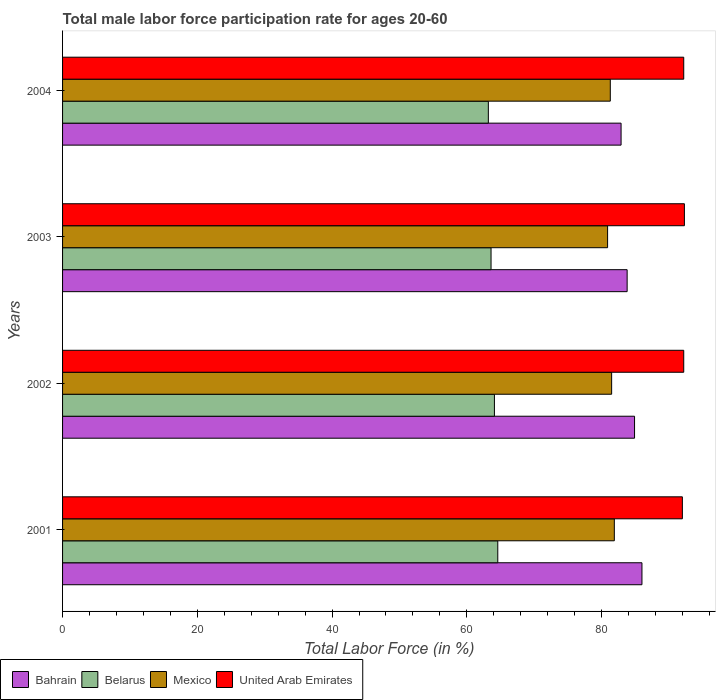How many groups of bars are there?
Offer a terse response. 4. Are the number of bars on each tick of the Y-axis equal?
Your response must be concise. Yes. How many bars are there on the 4th tick from the bottom?
Your answer should be very brief. 4. What is the label of the 3rd group of bars from the top?
Provide a succinct answer. 2002. What is the male labor force participation rate in Belarus in 2004?
Keep it short and to the point. 63.2. Across all years, what is the minimum male labor force participation rate in Belarus?
Make the answer very short. 63.2. What is the total male labor force participation rate in Bahrain in the graph?
Give a very brief answer. 337.6. What is the difference between the male labor force participation rate in Belarus in 2003 and that in 2004?
Keep it short and to the point. 0.4. What is the difference between the male labor force participation rate in Mexico in 2004 and the male labor force participation rate in Bahrain in 2003?
Ensure brevity in your answer.  -2.5. What is the average male labor force participation rate in United Arab Emirates per year?
Offer a terse response. 92.17. In the year 2003, what is the difference between the male labor force participation rate in Bahrain and male labor force participation rate in Belarus?
Provide a short and direct response. 20.2. In how many years, is the male labor force participation rate in United Arab Emirates greater than 68 %?
Your response must be concise. 4. What is the ratio of the male labor force participation rate in Mexico in 2002 to that in 2003?
Give a very brief answer. 1.01. Is the male labor force participation rate in Belarus in 2003 less than that in 2004?
Provide a succinct answer. No. What is the difference between the highest and the second highest male labor force participation rate in Bahrain?
Your answer should be compact. 1.1. What is the difference between the highest and the lowest male labor force participation rate in United Arab Emirates?
Provide a short and direct response. 0.3. Is the sum of the male labor force participation rate in Belarus in 2003 and 2004 greater than the maximum male labor force participation rate in Bahrain across all years?
Provide a short and direct response. Yes. What does the 1st bar from the top in 2001 represents?
Give a very brief answer. United Arab Emirates. What does the 3rd bar from the bottom in 2003 represents?
Your answer should be very brief. Mexico. How many bars are there?
Give a very brief answer. 16. Are all the bars in the graph horizontal?
Offer a terse response. Yes. How many years are there in the graph?
Provide a short and direct response. 4. What is the difference between two consecutive major ticks on the X-axis?
Provide a short and direct response. 20. Does the graph contain any zero values?
Ensure brevity in your answer.  No. Does the graph contain grids?
Your answer should be compact. No. How are the legend labels stacked?
Keep it short and to the point. Horizontal. What is the title of the graph?
Your response must be concise. Total male labor force participation rate for ages 20-60. What is the label or title of the X-axis?
Provide a succinct answer. Total Labor Force (in %). What is the label or title of the Y-axis?
Offer a terse response. Years. What is the Total Labor Force (in %) of Bahrain in 2001?
Your answer should be compact. 86. What is the Total Labor Force (in %) in Belarus in 2001?
Your response must be concise. 64.6. What is the Total Labor Force (in %) of Mexico in 2001?
Ensure brevity in your answer.  81.9. What is the Total Labor Force (in %) of United Arab Emirates in 2001?
Keep it short and to the point. 92. What is the Total Labor Force (in %) in Bahrain in 2002?
Provide a short and direct response. 84.9. What is the Total Labor Force (in %) of Belarus in 2002?
Ensure brevity in your answer.  64.1. What is the Total Labor Force (in %) of Mexico in 2002?
Your answer should be very brief. 81.5. What is the Total Labor Force (in %) of United Arab Emirates in 2002?
Your answer should be very brief. 92.2. What is the Total Labor Force (in %) in Bahrain in 2003?
Your answer should be compact. 83.8. What is the Total Labor Force (in %) of Belarus in 2003?
Your response must be concise. 63.6. What is the Total Labor Force (in %) in Mexico in 2003?
Offer a very short reply. 80.9. What is the Total Labor Force (in %) in United Arab Emirates in 2003?
Ensure brevity in your answer.  92.3. What is the Total Labor Force (in %) of Bahrain in 2004?
Your answer should be very brief. 82.9. What is the Total Labor Force (in %) of Belarus in 2004?
Give a very brief answer. 63.2. What is the Total Labor Force (in %) in Mexico in 2004?
Provide a succinct answer. 81.3. What is the Total Labor Force (in %) of United Arab Emirates in 2004?
Provide a succinct answer. 92.2. Across all years, what is the maximum Total Labor Force (in %) in Bahrain?
Make the answer very short. 86. Across all years, what is the maximum Total Labor Force (in %) in Belarus?
Provide a short and direct response. 64.6. Across all years, what is the maximum Total Labor Force (in %) in Mexico?
Give a very brief answer. 81.9. Across all years, what is the maximum Total Labor Force (in %) in United Arab Emirates?
Give a very brief answer. 92.3. Across all years, what is the minimum Total Labor Force (in %) in Bahrain?
Your response must be concise. 82.9. Across all years, what is the minimum Total Labor Force (in %) of Belarus?
Provide a succinct answer. 63.2. Across all years, what is the minimum Total Labor Force (in %) of Mexico?
Give a very brief answer. 80.9. Across all years, what is the minimum Total Labor Force (in %) of United Arab Emirates?
Provide a succinct answer. 92. What is the total Total Labor Force (in %) of Bahrain in the graph?
Your answer should be compact. 337.6. What is the total Total Labor Force (in %) of Belarus in the graph?
Your response must be concise. 255.5. What is the total Total Labor Force (in %) in Mexico in the graph?
Ensure brevity in your answer.  325.6. What is the total Total Labor Force (in %) in United Arab Emirates in the graph?
Your answer should be compact. 368.7. What is the difference between the Total Labor Force (in %) in Bahrain in 2001 and that in 2002?
Your response must be concise. 1.1. What is the difference between the Total Labor Force (in %) in Belarus in 2001 and that in 2002?
Provide a short and direct response. 0.5. What is the difference between the Total Labor Force (in %) of Mexico in 2001 and that in 2002?
Your answer should be very brief. 0.4. What is the difference between the Total Labor Force (in %) of United Arab Emirates in 2001 and that in 2002?
Offer a very short reply. -0.2. What is the difference between the Total Labor Force (in %) in Belarus in 2001 and that in 2003?
Give a very brief answer. 1. What is the difference between the Total Labor Force (in %) of Mexico in 2001 and that in 2003?
Make the answer very short. 1. What is the difference between the Total Labor Force (in %) in Belarus in 2001 and that in 2004?
Provide a short and direct response. 1.4. What is the difference between the Total Labor Force (in %) of Mexico in 2001 and that in 2004?
Your response must be concise. 0.6. What is the difference between the Total Labor Force (in %) in United Arab Emirates in 2001 and that in 2004?
Ensure brevity in your answer.  -0.2. What is the difference between the Total Labor Force (in %) in Bahrain in 2002 and that in 2003?
Provide a short and direct response. 1.1. What is the difference between the Total Labor Force (in %) in Belarus in 2002 and that in 2003?
Your response must be concise. 0.5. What is the difference between the Total Labor Force (in %) in Belarus in 2002 and that in 2004?
Your answer should be very brief. 0.9. What is the difference between the Total Labor Force (in %) of United Arab Emirates in 2002 and that in 2004?
Your answer should be very brief. 0. What is the difference between the Total Labor Force (in %) of Belarus in 2003 and that in 2004?
Provide a succinct answer. 0.4. What is the difference between the Total Labor Force (in %) of Mexico in 2003 and that in 2004?
Offer a terse response. -0.4. What is the difference between the Total Labor Force (in %) of Bahrain in 2001 and the Total Labor Force (in %) of Belarus in 2002?
Give a very brief answer. 21.9. What is the difference between the Total Labor Force (in %) of Belarus in 2001 and the Total Labor Force (in %) of Mexico in 2002?
Ensure brevity in your answer.  -16.9. What is the difference between the Total Labor Force (in %) in Belarus in 2001 and the Total Labor Force (in %) in United Arab Emirates in 2002?
Provide a short and direct response. -27.6. What is the difference between the Total Labor Force (in %) of Bahrain in 2001 and the Total Labor Force (in %) of Belarus in 2003?
Offer a very short reply. 22.4. What is the difference between the Total Labor Force (in %) in Bahrain in 2001 and the Total Labor Force (in %) in Mexico in 2003?
Your answer should be very brief. 5.1. What is the difference between the Total Labor Force (in %) in Belarus in 2001 and the Total Labor Force (in %) in Mexico in 2003?
Offer a very short reply. -16.3. What is the difference between the Total Labor Force (in %) in Belarus in 2001 and the Total Labor Force (in %) in United Arab Emirates in 2003?
Provide a short and direct response. -27.7. What is the difference between the Total Labor Force (in %) in Mexico in 2001 and the Total Labor Force (in %) in United Arab Emirates in 2003?
Offer a terse response. -10.4. What is the difference between the Total Labor Force (in %) in Bahrain in 2001 and the Total Labor Force (in %) in Belarus in 2004?
Keep it short and to the point. 22.8. What is the difference between the Total Labor Force (in %) of Bahrain in 2001 and the Total Labor Force (in %) of Mexico in 2004?
Offer a very short reply. 4.7. What is the difference between the Total Labor Force (in %) in Bahrain in 2001 and the Total Labor Force (in %) in United Arab Emirates in 2004?
Offer a very short reply. -6.2. What is the difference between the Total Labor Force (in %) in Belarus in 2001 and the Total Labor Force (in %) in Mexico in 2004?
Provide a short and direct response. -16.7. What is the difference between the Total Labor Force (in %) of Belarus in 2001 and the Total Labor Force (in %) of United Arab Emirates in 2004?
Your response must be concise. -27.6. What is the difference between the Total Labor Force (in %) of Mexico in 2001 and the Total Labor Force (in %) of United Arab Emirates in 2004?
Give a very brief answer. -10.3. What is the difference between the Total Labor Force (in %) in Bahrain in 2002 and the Total Labor Force (in %) in Belarus in 2003?
Give a very brief answer. 21.3. What is the difference between the Total Labor Force (in %) in Bahrain in 2002 and the Total Labor Force (in %) in Mexico in 2003?
Make the answer very short. 4. What is the difference between the Total Labor Force (in %) of Bahrain in 2002 and the Total Labor Force (in %) of United Arab Emirates in 2003?
Provide a short and direct response. -7.4. What is the difference between the Total Labor Force (in %) of Belarus in 2002 and the Total Labor Force (in %) of Mexico in 2003?
Keep it short and to the point. -16.8. What is the difference between the Total Labor Force (in %) in Belarus in 2002 and the Total Labor Force (in %) in United Arab Emirates in 2003?
Your answer should be very brief. -28.2. What is the difference between the Total Labor Force (in %) of Mexico in 2002 and the Total Labor Force (in %) of United Arab Emirates in 2003?
Ensure brevity in your answer.  -10.8. What is the difference between the Total Labor Force (in %) of Bahrain in 2002 and the Total Labor Force (in %) of Belarus in 2004?
Ensure brevity in your answer.  21.7. What is the difference between the Total Labor Force (in %) in Bahrain in 2002 and the Total Labor Force (in %) in United Arab Emirates in 2004?
Keep it short and to the point. -7.3. What is the difference between the Total Labor Force (in %) of Belarus in 2002 and the Total Labor Force (in %) of Mexico in 2004?
Give a very brief answer. -17.2. What is the difference between the Total Labor Force (in %) in Belarus in 2002 and the Total Labor Force (in %) in United Arab Emirates in 2004?
Your response must be concise. -28.1. What is the difference between the Total Labor Force (in %) in Bahrain in 2003 and the Total Labor Force (in %) in Belarus in 2004?
Make the answer very short. 20.6. What is the difference between the Total Labor Force (in %) of Bahrain in 2003 and the Total Labor Force (in %) of Mexico in 2004?
Offer a terse response. 2.5. What is the difference between the Total Labor Force (in %) in Bahrain in 2003 and the Total Labor Force (in %) in United Arab Emirates in 2004?
Your response must be concise. -8.4. What is the difference between the Total Labor Force (in %) of Belarus in 2003 and the Total Labor Force (in %) of Mexico in 2004?
Offer a very short reply. -17.7. What is the difference between the Total Labor Force (in %) of Belarus in 2003 and the Total Labor Force (in %) of United Arab Emirates in 2004?
Your response must be concise. -28.6. What is the difference between the Total Labor Force (in %) of Mexico in 2003 and the Total Labor Force (in %) of United Arab Emirates in 2004?
Give a very brief answer. -11.3. What is the average Total Labor Force (in %) of Bahrain per year?
Your response must be concise. 84.4. What is the average Total Labor Force (in %) of Belarus per year?
Provide a succinct answer. 63.88. What is the average Total Labor Force (in %) of Mexico per year?
Provide a short and direct response. 81.4. What is the average Total Labor Force (in %) of United Arab Emirates per year?
Make the answer very short. 92.17. In the year 2001, what is the difference between the Total Labor Force (in %) in Bahrain and Total Labor Force (in %) in Belarus?
Provide a short and direct response. 21.4. In the year 2001, what is the difference between the Total Labor Force (in %) in Bahrain and Total Labor Force (in %) in United Arab Emirates?
Provide a succinct answer. -6. In the year 2001, what is the difference between the Total Labor Force (in %) of Belarus and Total Labor Force (in %) of Mexico?
Keep it short and to the point. -17.3. In the year 2001, what is the difference between the Total Labor Force (in %) in Belarus and Total Labor Force (in %) in United Arab Emirates?
Ensure brevity in your answer.  -27.4. In the year 2002, what is the difference between the Total Labor Force (in %) of Bahrain and Total Labor Force (in %) of Belarus?
Your answer should be compact. 20.8. In the year 2002, what is the difference between the Total Labor Force (in %) of Bahrain and Total Labor Force (in %) of United Arab Emirates?
Offer a terse response. -7.3. In the year 2002, what is the difference between the Total Labor Force (in %) of Belarus and Total Labor Force (in %) of Mexico?
Offer a very short reply. -17.4. In the year 2002, what is the difference between the Total Labor Force (in %) of Belarus and Total Labor Force (in %) of United Arab Emirates?
Give a very brief answer. -28.1. In the year 2003, what is the difference between the Total Labor Force (in %) in Bahrain and Total Labor Force (in %) in Belarus?
Make the answer very short. 20.2. In the year 2003, what is the difference between the Total Labor Force (in %) in Belarus and Total Labor Force (in %) in Mexico?
Provide a short and direct response. -17.3. In the year 2003, what is the difference between the Total Labor Force (in %) of Belarus and Total Labor Force (in %) of United Arab Emirates?
Provide a short and direct response. -28.7. In the year 2003, what is the difference between the Total Labor Force (in %) of Mexico and Total Labor Force (in %) of United Arab Emirates?
Your answer should be compact. -11.4. In the year 2004, what is the difference between the Total Labor Force (in %) in Bahrain and Total Labor Force (in %) in Belarus?
Provide a succinct answer. 19.7. In the year 2004, what is the difference between the Total Labor Force (in %) of Belarus and Total Labor Force (in %) of Mexico?
Offer a terse response. -18.1. In the year 2004, what is the difference between the Total Labor Force (in %) of Belarus and Total Labor Force (in %) of United Arab Emirates?
Your response must be concise. -29. What is the ratio of the Total Labor Force (in %) in Belarus in 2001 to that in 2002?
Your answer should be very brief. 1.01. What is the ratio of the Total Labor Force (in %) of Bahrain in 2001 to that in 2003?
Your response must be concise. 1.03. What is the ratio of the Total Labor Force (in %) in Belarus in 2001 to that in 2003?
Keep it short and to the point. 1.02. What is the ratio of the Total Labor Force (in %) in Mexico in 2001 to that in 2003?
Offer a very short reply. 1.01. What is the ratio of the Total Labor Force (in %) in Bahrain in 2001 to that in 2004?
Make the answer very short. 1.04. What is the ratio of the Total Labor Force (in %) in Belarus in 2001 to that in 2004?
Provide a short and direct response. 1.02. What is the ratio of the Total Labor Force (in %) in Mexico in 2001 to that in 2004?
Provide a succinct answer. 1.01. What is the ratio of the Total Labor Force (in %) of Bahrain in 2002 to that in 2003?
Make the answer very short. 1.01. What is the ratio of the Total Labor Force (in %) in Belarus in 2002 to that in 2003?
Your response must be concise. 1.01. What is the ratio of the Total Labor Force (in %) of Mexico in 2002 to that in 2003?
Make the answer very short. 1.01. What is the ratio of the Total Labor Force (in %) in Bahrain in 2002 to that in 2004?
Give a very brief answer. 1.02. What is the ratio of the Total Labor Force (in %) of Belarus in 2002 to that in 2004?
Give a very brief answer. 1.01. What is the ratio of the Total Labor Force (in %) in United Arab Emirates in 2002 to that in 2004?
Keep it short and to the point. 1. What is the ratio of the Total Labor Force (in %) in Bahrain in 2003 to that in 2004?
Your answer should be very brief. 1.01. What is the ratio of the Total Labor Force (in %) in Mexico in 2003 to that in 2004?
Ensure brevity in your answer.  1. What is the difference between the highest and the second highest Total Labor Force (in %) in Bahrain?
Provide a short and direct response. 1.1. What is the difference between the highest and the second highest Total Labor Force (in %) of Belarus?
Make the answer very short. 0.5. What is the difference between the highest and the second highest Total Labor Force (in %) in Mexico?
Give a very brief answer. 0.4. What is the difference between the highest and the second highest Total Labor Force (in %) of United Arab Emirates?
Make the answer very short. 0.1. What is the difference between the highest and the lowest Total Labor Force (in %) of Belarus?
Offer a very short reply. 1.4. What is the difference between the highest and the lowest Total Labor Force (in %) of Mexico?
Your response must be concise. 1. 